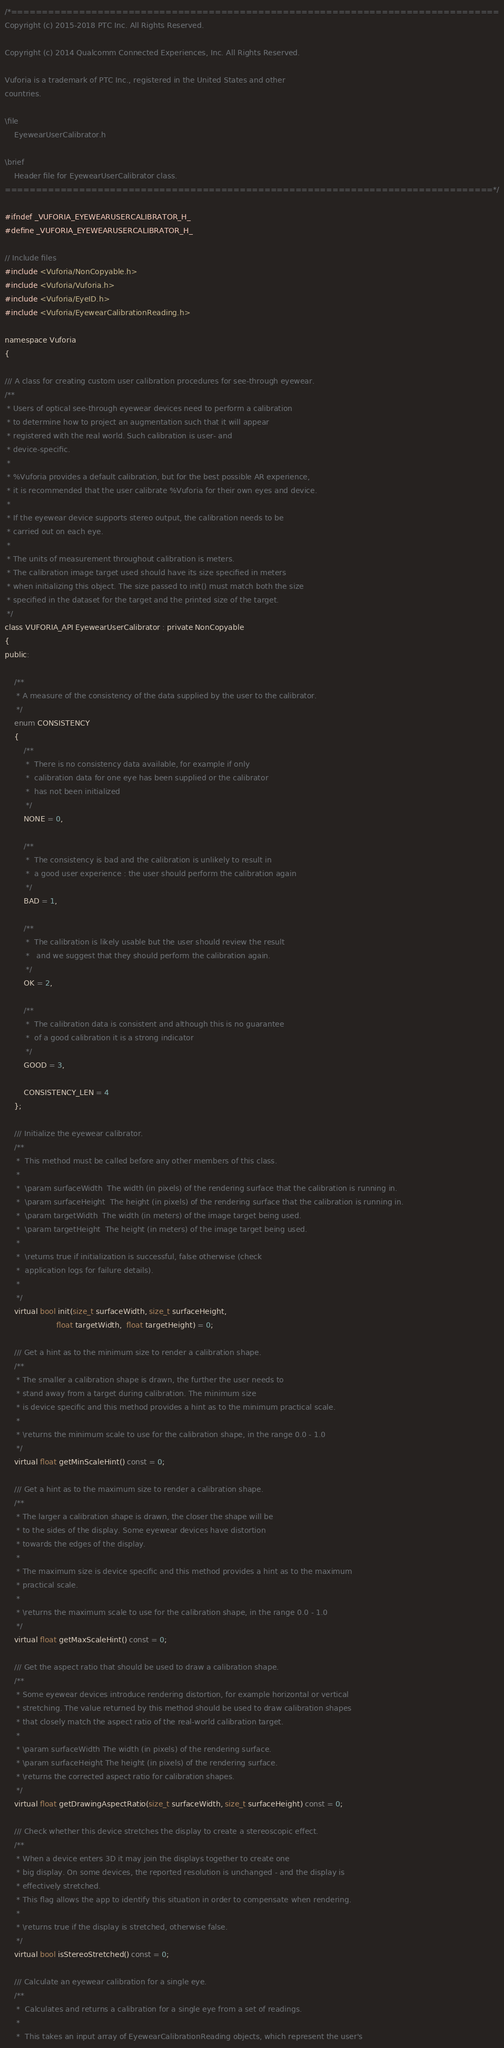<code> <loc_0><loc_0><loc_500><loc_500><_C_>/*===============================================================================
Copyright (c) 2015-2018 PTC Inc. All Rights Reserved.

Copyright (c) 2014 Qualcomm Connected Experiences, Inc. All Rights Reserved.

Vuforia is a trademark of PTC Inc., registered in the United States and other 
countries.

\file
    EyewearUserCalibrator.h

\brief
    Header file for EyewearUserCalibrator class.
===============================================================================*/

#ifndef _VUFORIA_EYEWEARUSERCALIBRATOR_H_
#define _VUFORIA_EYEWEARUSERCALIBRATOR_H_

// Include files
#include <Vuforia/NonCopyable.h>
#include <Vuforia/Vuforia.h>
#include <Vuforia/EyeID.h>
#include <Vuforia/EyewearCalibrationReading.h>

namespace Vuforia
{

/// A class for creating custom user calibration procedures for see-through eyewear.
/**
 * Users of optical see-through eyewear devices need to perform a calibration
 * to determine how to project an augmentation such that it will appear
 * registered with the real world. Such calibration is user- and
 * device-specific.
 *
 * %Vuforia provides a default calibration, but for the best possible AR experience,
 * it is recommended that the user calibrate %Vuforia for their own eyes and device.
 *
 * If the eyewear device supports stereo output, the calibration needs to be
 * carried out on each eye.
 *
 * The units of measurement throughout calibration is meters.
 * The calibration image target used should have its size specified in meters
 * when initializing this object. The size passed to init() must match both the size
 * specified in the dataset for the target and the printed size of the target.
 */
class VUFORIA_API EyewearUserCalibrator : private NonCopyable
{
public:

    /**
     * A measure of the consistency of the data supplied by the user to the calibrator.
     */
    enum CONSISTENCY
    {
        /**
         *  There is no consistency data available, for example if only
         *  calibration data for one eye has been supplied or the calibrator
         *  has not been initialized
         */
        NONE = 0,

        /**
         *  The consistency is bad and the calibration is unlikely to result in
         *  a good user experience : the user should perform the calibration again
         */
        BAD = 1,

        /**
         *  The calibration is likely usable but the user should review the result
         *   and we suggest that they should perform the calibration again.
         */
        OK = 2,

        /**
         *  The calibration data is consistent and although this is no guarantee
         *  of a good calibration it is a strong indicator
         */
        GOOD = 3,

        CONSISTENCY_LEN = 4
    };

    /// Initialize the eyewear calibrator.
    /**
     *  This method must be called before any other members of this class.
     *
     *  \param surfaceWidth  The width (in pixels) of the rendering surface that the calibration is running in.
     *  \param surfaceHeight  The height (in pixels) of the rendering surface that the calibration is running in.
     *  \param targetWidth  The width (in meters) of the image target being used.
     *  \param targetHeight  The height (in meters) of the image target being used.
     *  
     *  \returns true if initialization is successful, false otherwise (check
     *  application logs for failure details).
     *
     */
    virtual bool init(size_t surfaceWidth, size_t surfaceHeight,
                      float targetWidth,  float targetHeight) = 0;

    /// Get a hint as to the minimum size to render a calibration shape.
    /**
     * The smaller a calibration shape is drawn, the further the user needs to
     * stand away from a target during calibration. The minimum size
     * is device specific and this method provides a hint as to the minimum practical scale.
     *
     * \returns the minimum scale to use for the calibration shape, in the range 0.0 - 1.0
     */
    virtual float getMinScaleHint() const = 0; 

    /// Get a hint as to the maximum size to render a calibration shape.
    /**
     * The larger a calibration shape is drawn, the closer the shape will be
     * to the sides of the display. Some eyewear devices have distortion
     * towards the edges of the display.
     *
     * The maximum size is device specific and this method provides a hint as to the maximum
     * practical scale.
     *
     * \returns the maximum scale to use for the calibration shape, in the range 0.0 - 1.0
     */
    virtual float getMaxScaleHint() const = 0;

    /// Get the aspect ratio that should be used to draw a calibration shape.
    /**
     * Some eyewear devices introduce rendering distortion, for example horizontal or vertical
     * stretching. The value returned by this method should be used to draw calibration shapes
     * that closely match the aspect ratio of the real-world calibration target.
     *
     * \param surfaceWidth The width (in pixels) of the rendering surface.
     * \param surfaceHeight The height (in pixels) of the rendering surface.
     * \returns the corrected aspect ratio for calibration shapes.
     */
    virtual float getDrawingAspectRatio(size_t surfaceWidth, size_t surfaceHeight) const = 0;

    /// Check whether this device stretches the display to create a stereoscopic effect.
    /**
     * When a device enters 3D it may join the displays together to create one
     * big display. On some devices, the reported resolution is unchanged - and the display is
     * effectively stretched.
     * This flag allows the app to identify this situation in order to compensate when rendering.
     *
     * \returns true if the display is stretched, otherwise false.
     */
    virtual bool isStereoStretched() const = 0;

    /// Calculate an eyewear calibration for a single eye.
    /**
     *  Calculates and returns a calibration for a single eye from a set of readings.
     *
     *  This takes an input array of EyewearCalibrationReading objects, which represent the user's</code> 